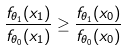Convert formula to latex. <formula><loc_0><loc_0><loc_500><loc_500>\frac { f _ { \theta _ { 1 } } ( x _ { 1 } ) } { f _ { \theta _ { 0 } } ( x _ { 1 } ) } \geq \frac { f _ { \theta _ { 1 } } ( x _ { 0 } ) } { f _ { \theta _ { 0 } } ( x _ { 0 } ) }</formula> 